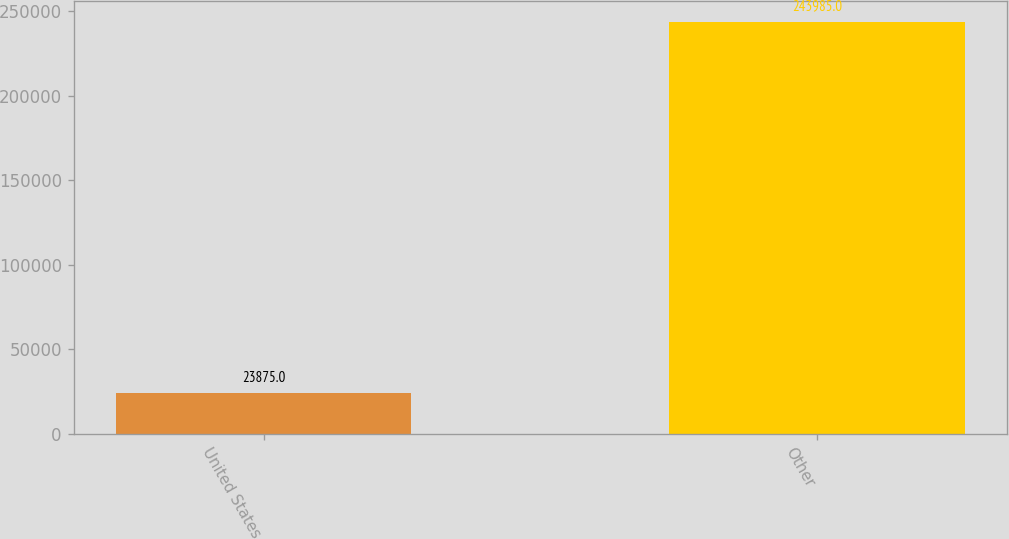Convert chart to OTSL. <chart><loc_0><loc_0><loc_500><loc_500><bar_chart><fcel>United States<fcel>Other<nl><fcel>23875<fcel>243985<nl></chart> 